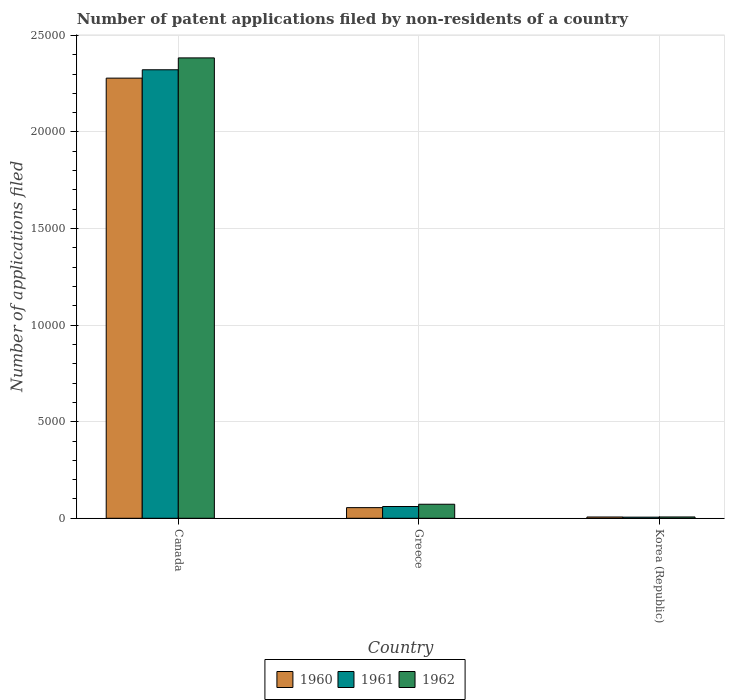How many different coloured bars are there?
Provide a succinct answer. 3. How many groups of bars are there?
Provide a succinct answer. 3. Are the number of bars per tick equal to the number of legend labels?
Your answer should be very brief. Yes. How many bars are there on the 1st tick from the right?
Provide a short and direct response. 3. What is the number of applications filed in 1960 in Korea (Republic)?
Offer a terse response. 66. Across all countries, what is the maximum number of applications filed in 1962?
Provide a short and direct response. 2.38e+04. What is the total number of applications filed in 1961 in the graph?
Offer a terse response. 2.39e+04. What is the difference between the number of applications filed in 1961 in Greece and that in Korea (Republic)?
Your answer should be very brief. 551. What is the difference between the number of applications filed in 1961 in Greece and the number of applications filed in 1960 in Canada?
Offer a very short reply. -2.22e+04. What is the average number of applications filed in 1962 per country?
Offer a very short reply. 8209.33. What is the difference between the number of applications filed of/in 1962 and number of applications filed of/in 1961 in Korea (Republic)?
Offer a terse response. 10. What is the ratio of the number of applications filed in 1960 in Canada to that in Greece?
Your response must be concise. 41.35. Is the number of applications filed in 1960 in Canada less than that in Greece?
Keep it short and to the point. No. What is the difference between the highest and the second highest number of applications filed in 1961?
Provide a short and direct response. 551. What is the difference between the highest and the lowest number of applications filed in 1962?
Your response must be concise. 2.38e+04. Is the sum of the number of applications filed in 1961 in Canada and Greece greater than the maximum number of applications filed in 1960 across all countries?
Provide a succinct answer. Yes. What does the 2nd bar from the right in Greece represents?
Offer a terse response. 1961. Are all the bars in the graph horizontal?
Your response must be concise. No. How many countries are there in the graph?
Make the answer very short. 3. Does the graph contain any zero values?
Provide a succinct answer. No. What is the title of the graph?
Give a very brief answer. Number of patent applications filed by non-residents of a country. Does "1960" appear as one of the legend labels in the graph?
Offer a very short reply. Yes. What is the label or title of the X-axis?
Your answer should be very brief. Country. What is the label or title of the Y-axis?
Your response must be concise. Number of applications filed. What is the Number of applications filed of 1960 in Canada?
Provide a short and direct response. 2.28e+04. What is the Number of applications filed of 1961 in Canada?
Your answer should be compact. 2.32e+04. What is the Number of applications filed in 1962 in Canada?
Provide a succinct answer. 2.38e+04. What is the Number of applications filed of 1960 in Greece?
Give a very brief answer. 551. What is the Number of applications filed of 1961 in Greece?
Make the answer very short. 609. What is the Number of applications filed of 1962 in Greece?
Give a very brief answer. 726. Across all countries, what is the maximum Number of applications filed of 1960?
Your answer should be compact. 2.28e+04. Across all countries, what is the maximum Number of applications filed in 1961?
Offer a very short reply. 2.32e+04. Across all countries, what is the maximum Number of applications filed in 1962?
Ensure brevity in your answer.  2.38e+04. Across all countries, what is the minimum Number of applications filed in 1960?
Your answer should be compact. 66. Across all countries, what is the minimum Number of applications filed in 1961?
Give a very brief answer. 58. Across all countries, what is the minimum Number of applications filed in 1962?
Your answer should be compact. 68. What is the total Number of applications filed of 1960 in the graph?
Your answer should be very brief. 2.34e+04. What is the total Number of applications filed of 1961 in the graph?
Provide a short and direct response. 2.39e+04. What is the total Number of applications filed of 1962 in the graph?
Your response must be concise. 2.46e+04. What is the difference between the Number of applications filed in 1960 in Canada and that in Greece?
Give a very brief answer. 2.22e+04. What is the difference between the Number of applications filed of 1961 in Canada and that in Greece?
Make the answer very short. 2.26e+04. What is the difference between the Number of applications filed in 1962 in Canada and that in Greece?
Give a very brief answer. 2.31e+04. What is the difference between the Number of applications filed of 1960 in Canada and that in Korea (Republic)?
Give a very brief answer. 2.27e+04. What is the difference between the Number of applications filed of 1961 in Canada and that in Korea (Republic)?
Ensure brevity in your answer.  2.32e+04. What is the difference between the Number of applications filed in 1962 in Canada and that in Korea (Republic)?
Your answer should be very brief. 2.38e+04. What is the difference between the Number of applications filed of 1960 in Greece and that in Korea (Republic)?
Provide a succinct answer. 485. What is the difference between the Number of applications filed of 1961 in Greece and that in Korea (Republic)?
Offer a terse response. 551. What is the difference between the Number of applications filed of 1962 in Greece and that in Korea (Republic)?
Provide a short and direct response. 658. What is the difference between the Number of applications filed in 1960 in Canada and the Number of applications filed in 1961 in Greece?
Provide a succinct answer. 2.22e+04. What is the difference between the Number of applications filed in 1960 in Canada and the Number of applications filed in 1962 in Greece?
Provide a short and direct response. 2.21e+04. What is the difference between the Number of applications filed in 1961 in Canada and the Number of applications filed in 1962 in Greece?
Offer a very short reply. 2.25e+04. What is the difference between the Number of applications filed of 1960 in Canada and the Number of applications filed of 1961 in Korea (Republic)?
Provide a short and direct response. 2.27e+04. What is the difference between the Number of applications filed of 1960 in Canada and the Number of applications filed of 1962 in Korea (Republic)?
Offer a very short reply. 2.27e+04. What is the difference between the Number of applications filed of 1961 in Canada and the Number of applications filed of 1962 in Korea (Republic)?
Your answer should be very brief. 2.32e+04. What is the difference between the Number of applications filed of 1960 in Greece and the Number of applications filed of 1961 in Korea (Republic)?
Offer a very short reply. 493. What is the difference between the Number of applications filed of 1960 in Greece and the Number of applications filed of 1962 in Korea (Republic)?
Provide a succinct answer. 483. What is the difference between the Number of applications filed in 1961 in Greece and the Number of applications filed in 1962 in Korea (Republic)?
Keep it short and to the point. 541. What is the average Number of applications filed of 1960 per country?
Offer a terse response. 7801. What is the average Number of applications filed of 1961 per country?
Keep it short and to the point. 7962. What is the average Number of applications filed of 1962 per country?
Offer a very short reply. 8209.33. What is the difference between the Number of applications filed of 1960 and Number of applications filed of 1961 in Canada?
Provide a short and direct response. -433. What is the difference between the Number of applications filed of 1960 and Number of applications filed of 1962 in Canada?
Offer a very short reply. -1048. What is the difference between the Number of applications filed in 1961 and Number of applications filed in 1962 in Canada?
Offer a very short reply. -615. What is the difference between the Number of applications filed of 1960 and Number of applications filed of 1961 in Greece?
Provide a short and direct response. -58. What is the difference between the Number of applications filed in 1960 and Number of applications filed in 1962 in Greece?
Offer a very short reply. -175. What is the difference between the Number of applications filed in 1961 and Number of applications filed in 1962 in Greece?
Give a very brief answer. -117. What is the difference between the Number of applications filed in 1960 and Number of applications filed in 1961 in Korea (Republic)?
Offer a very short reply. 8. What is the difference between the Number of applications filed in 1960 and Number of applications filed in 1962 in Korea (Republic)?
Your answer should be very brief. -2. What is the ratio of the Number of applications filed of 1960 in Canada to that in Greece?
Ensure brevity in your answer.  41.35. What is the ratio of the Number of applications filed of 1961 in Canada to that in Greece?
Your response must be concise. 38.13. What is the ratio of the Number of applications filed in 1962 in Canada to that in Greece?
Ensure brevity in your answer.  32.83. What is the ratio of the Number of applications filed of 1960 in Canada to that in Korea (Republic)?
Provide a succinct answer. 345.24. What is the ratio of the Number of applications filed in 1961 in Canada to that in Korea (Republic)?
Provide a succinct answer. 400.33. What is the ratio of the Number of applications filed of 1962 in Canada to that in Korea (Republic)?
Make the answer very short. 350.5. What is the ratio of the Number of applications filed in 1960 in Greece to that in Korea (Republic)?
Offer a very short reply. 8.35. What is the ratio of the Number of applications filed in 1961 in Greece to that in Korea (Republic)?
Offer a very short reply. 10.5. What is the ratio of the Number of applications filed of 1962 in Greece to that in Korea (Republic)?
Your answer should be compact. 10.68. What is the difference between the highest and the second highest Number of applications filed of 1960?
Make the answer very short. 2.22e+04. What is the difference between the highest and the second highest Number of applications filed in 1961?
Your answer should be very brief. 2.26e+04. What is the difference between the highest and the second highest Number of applications filed of 1962?
Your answer should be very brief. 2.31e+04. What is the difference between the highest and the lowest Number of applications filed in 1960?
Ensure brevity in your answer.  2.27e+04. What is the difference between the highest and the lowest Number of applications filed of 1961?
Provide a succinct answer. 2.32e+04. What is the difference between the highest and the lowest Number of applications filed in 1962?
Make the answer very short. 2.38e+04. 